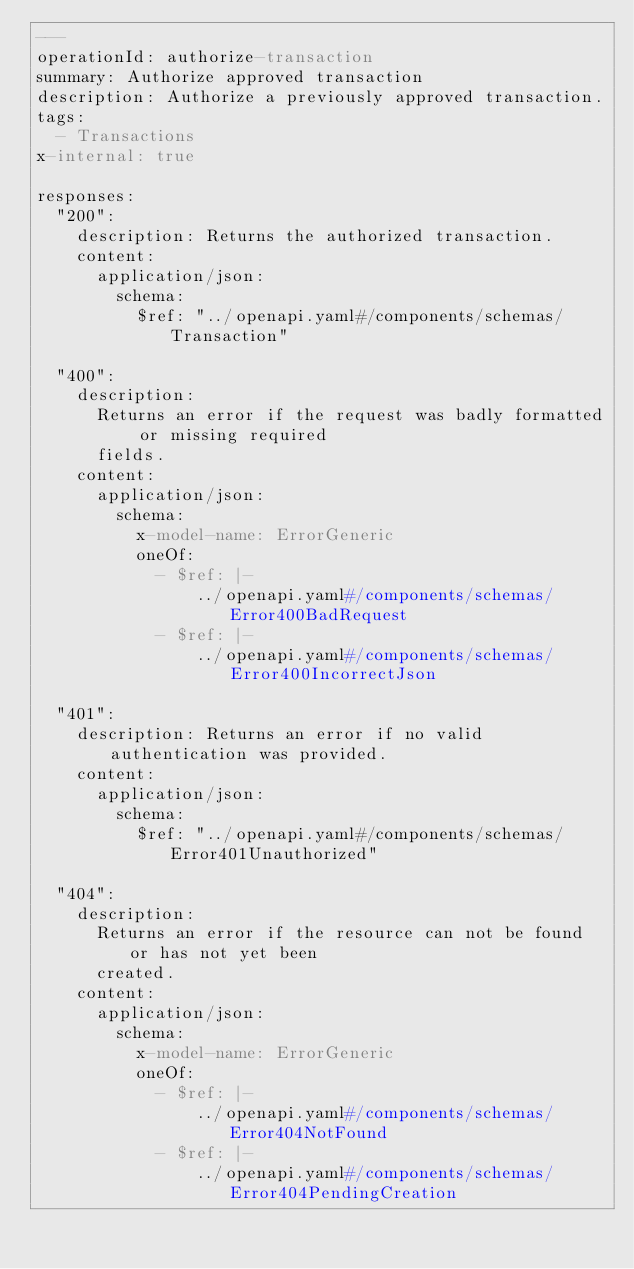Convert code to text. <code><loc_0><loc_0><loc_500><loc_500><_YAML_>---
operationId: authorize-transaction
summary: Authorize approved transaction
description: Authorize a previously approved transaction.
tags:
  - Transactions
x-internal: true

responses:
  "200":
    description: Returns the authorized transaction.
    content:
      application/json:
        schema:
          $ref: "../openapi.yaml#/components/schemas/Transaction"

  "400":
    description:
      Returns an error if the request was badly formatted or missing required
      fields.
    content:
      application/json:
        schema:
          x-model-name: ErrorGeneric
          oneOf:
            - $ref: |-
                ../openapi.yaml#/components/schemas/Error400BadRequest
            - $ref: |-
                ../openapi.yaml#/components/schemas/Error400IncorrectJson

  "401":
    description: Returns an error if no valid authentication was provided.
    content:
      application/json:
        schema:
          $ref: "../openapi.yaml#/components/schemas/Error401Unauthorized"

  "404":
    description:
      Returns an error if the resource can not be found or has not yet been
      created.
    content:
      application/json:
        schema:
          x-model-name: ErrorGeneric
          oneOf:
            - $ref: |-
                ../openapi.yaml#/components/schemas/Error404NotFound
            - $ref: |-
                ../openapi.yaml#/components/schemas/Error404PendingCreation
</code> 